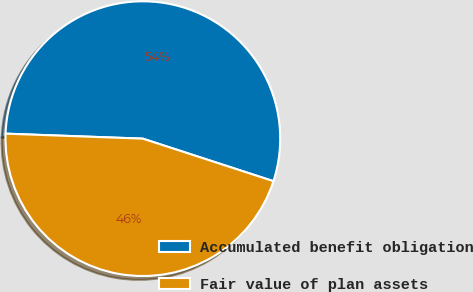<chart> <loc_0><loc_0><loc_500><loc_500><pie_chart><fcel>Accumulated benefit obligation<fcel>Fair value of plan assets<nl><fcel>54.43%<fcel>45.57%<nl></chart> 